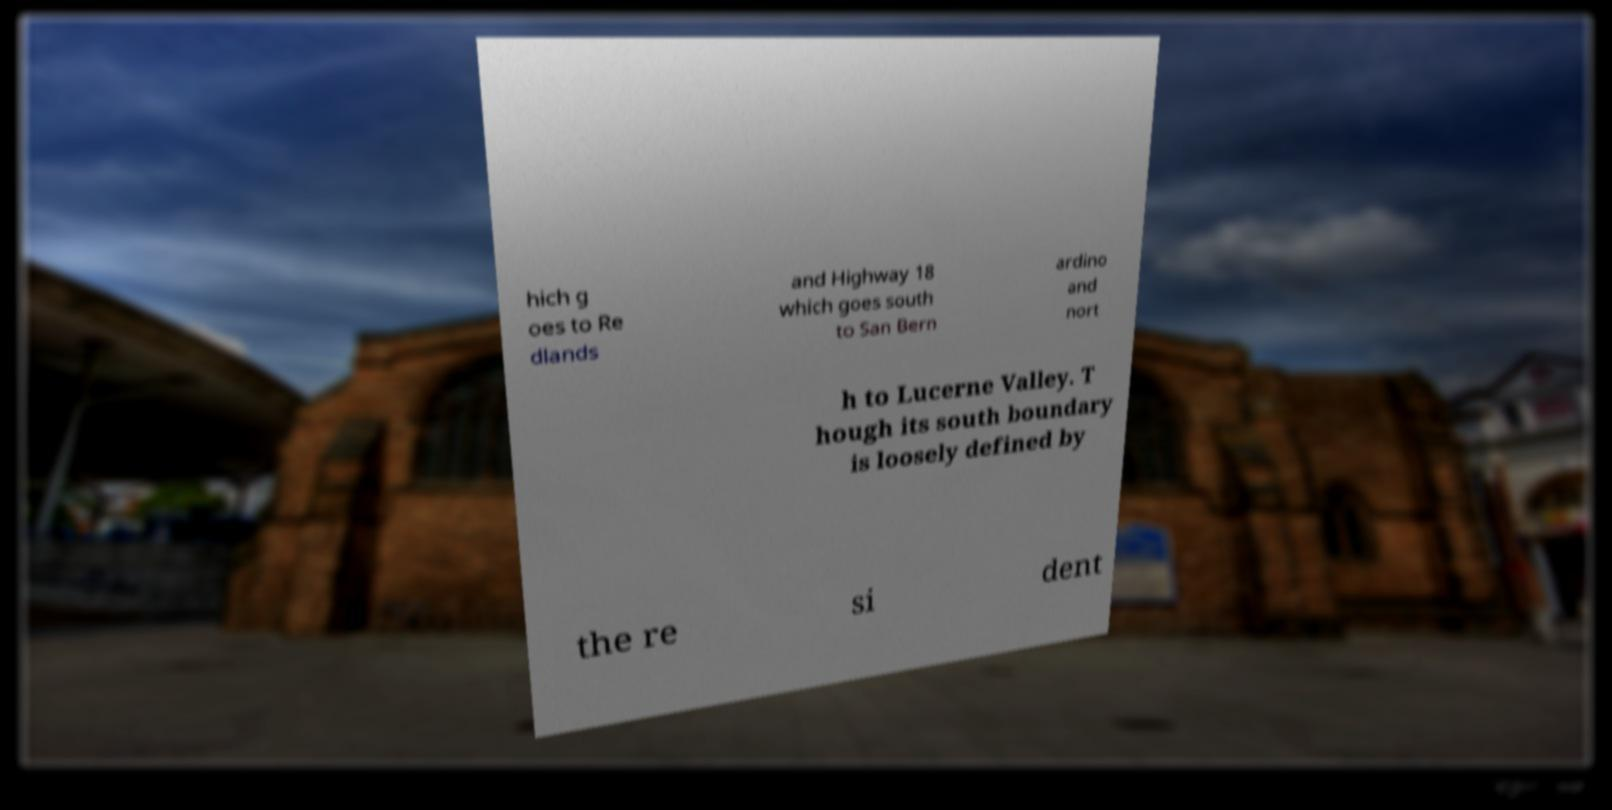Can you read and provide the text displayed in the image?This photo seems to have some interesting text. Can you extract and type it out for me? hich g oes to Re dlands and Highway 18 which goes south to San Bern ardino and nort h to Lucerne Valley. T hough its south boundary is loosely defined by the re si dent 